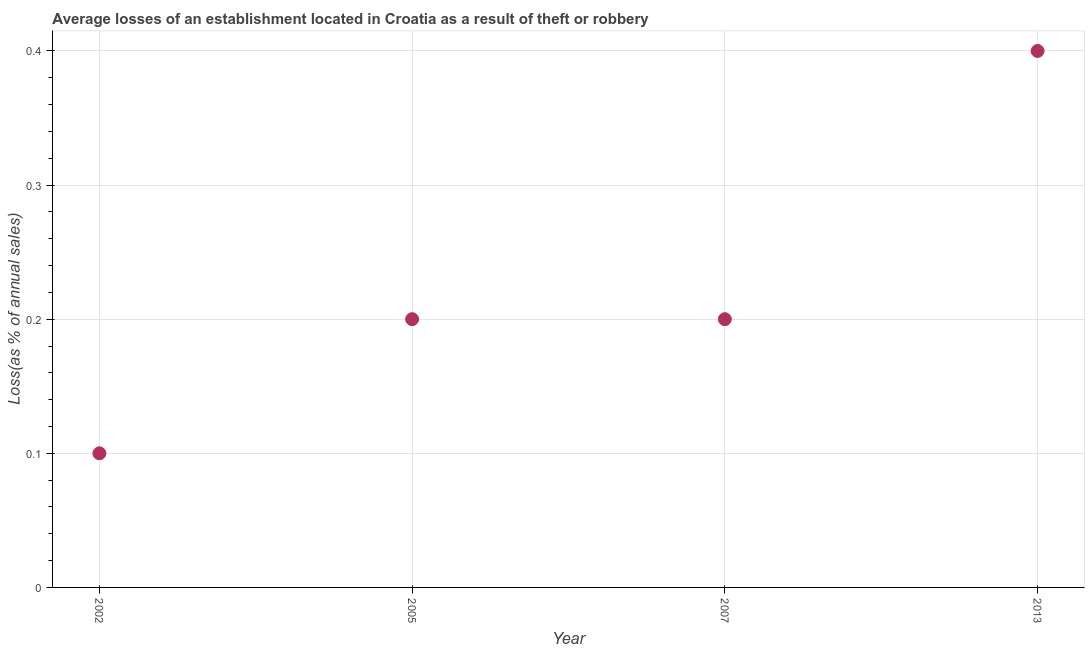What is the losses due to theft in 2013?
Offer a terse response. 0.4. Across all years, what is the minimum losses due to theft?
Provide a succinct answer. 0.1. What is the difference between the losses due to theft in 2002 and 2007?
Your response must be concise. -0.1. What is the average losses due to theft per year?
Your response must be concise. 0.23. What is the median losses due to theft?
Your response must be concise. 0.2. In how many years, is the losses due to theft greater than 0.28 %?
Your answer should be compact. 1. Do a majority of the years between 2002 and 2005 (inclusive) have losses due to theft greater than 0.1 %?
Offer a very short reply. No. Is the difference between the losses due to theft in 2002 and 2005 greater than the difference between any two years?
Your answer should be compact. No. What is the difference between the highest and the second highest losses due to theft?
Make the answer very short. 0.2. Is the sum of the losses due to theft in 2002 and 2007 greater than the maximum losses due to theft across all years?
Your answer should be compact. No. What is the difference between the highest and the lowest losses due to theft?
Offer a terse response. 0.3. How many dotlines are there?
Offer a terse response. 1. How many years are there in the graph?
Offer a terse response. 4. Are the values on the major ticks of Y-axis written in scientific E-notation?
Your answer should be very brief. No. What is the title of the graph?
Keep it short and to the point. Average losses of an establishment located in Croatia as a result of theft or robbery. What is the label or title of the X-axis?
Provide a succinct answer. Year. What is the label or title of the Y-axis?
Give a very brief answer. Loss(as % of annual sales). What is the Loss(as % of annual sales) in 2002?
Offer a very short reply. 0.1. What is the Loss(as % of annual sales) in 2013?
Give a very brief answer. 0.4. What is the difference between the Loss(as % of annual sales) in 2002 and 2007?
Give a very brief answer. -0.1. What is the difference between the Loss(as % of annual sales) in 2002 and 2013?
Provide a succinct answer. -0.3. What is the difference between the Loss(as % of annual sales) in 2005 and 2013?
Provide a succinct answer. -0.2. What is the difference between the Loss(as % of annual sales) in 2007 and 2013?
Offer a terse response. -0.2. What is the ratio of the Loss(as % of annual sales) in 2002 to that in 2005?
Your answer should be compact. 0.5. What is the ratio of the Loss(as % of annual sales) in 2005 to that in 2007?
Offer a very short reply. 1. 